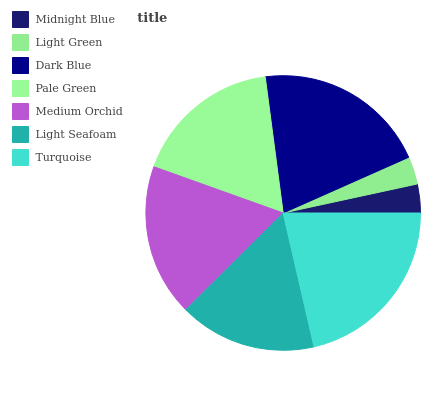Is Light Green the minimum?
Answer yes or no. Yes. Is Turquoise the maximum?
Answer yes or no. Yes. Is Dark Blue the minimum?
Answer yes or no. No. Is Dark Blue the maximum?
Answer yes or no. No. Is Dark Blue greater than Light Green?
Answer yes or no. Yes. Is Light Green less than Dark Blue?
Answer yes or no. Yes. Is Light Green greater than Dark Blue?
Answer yes or no. No. Is Dark Blue less than Light Green?
Answer yes or no. No. Is Pale Green the high median?
Answer yes or no. Yes. Is Pale Green the low median?
Answer yes or no. Yes. Is Dark Blue the high median?
Answer yes or no. No. Is Medium Orchid the low median?
Answer yes or no. No. 